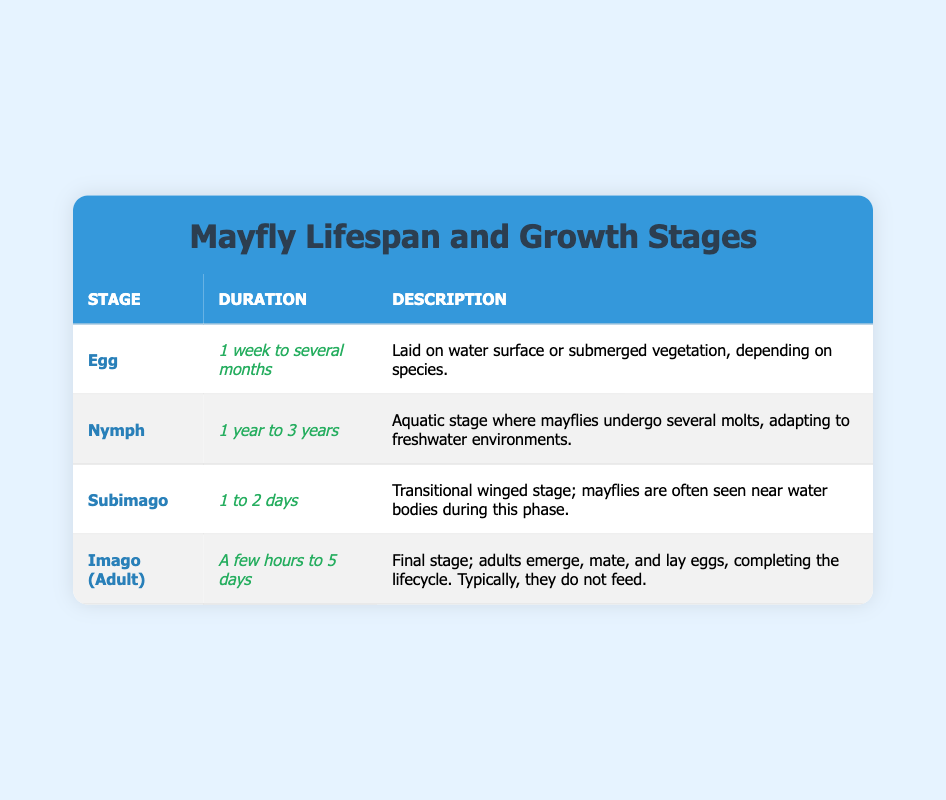What is the duration of the Egg stage? From the table, the duration of the Egg stage is clearly listed as "1 week to several months."
Answer: 1 week to several months How long does the Nymph stage last at maximum? The table indicates that the maximum duration for the Nymph stage is "3 years."
Answer: 3 years True or false: The Subimago stage lasts longer than the Imago stage. According to the table, the Subimago stage lasts "1 to 2 days," while the Imago stage lasts "a few hours to 5 days." Since a few hours is less than 1 day, the Imago stage can last longer than 2 days. Therefore, this statement is false.
Answer: False Which stage has the longest lifespan? By comparing the durations in the table, the Nymph stage has a lifespan of "1 year to 3 years," which is longer than the other stages.
Answer: Nymph stage How many stages have a duration of less than 2 days? The only stages with durations listed that are less than 2 days are the Subimago stage (1 to 2 days) and the Imago stage (a few hours to 5 days). Since the Imago stage can last for only a few hours, it counts as less than 2 days. Therefore, there are two stages with a duration of less than 2 days.
Answer: 2 stages What is the maximum duration of the Imago stage compared to the Nymph stage? The Imago stage has a maximum duration of "5 days," while the Nymph stage has a maximum duration of "3 years." Since 3 years is significantly longer than 5 days, the Nymph stage has a much longer maximum duration.
Answer: Nymph stage is longer In which stage do mayflies not feed? The table states that in the Imago (Adult) stage, it notes that typically, they do not feed.
Answer: Imago (Adult) stage What is the average duration of all stages listed? To find the average, calculate the mean of the duration ranges: Egg (average of 1 week and 2 months), Nymph (2 years, midpoint of the range), Subimago (1.5 days), and Imago (average of 2.5 days). Adding these values and then dividing by 4 gives an approximate average of roughly 1 year.
Answer: Approximately 1 year 